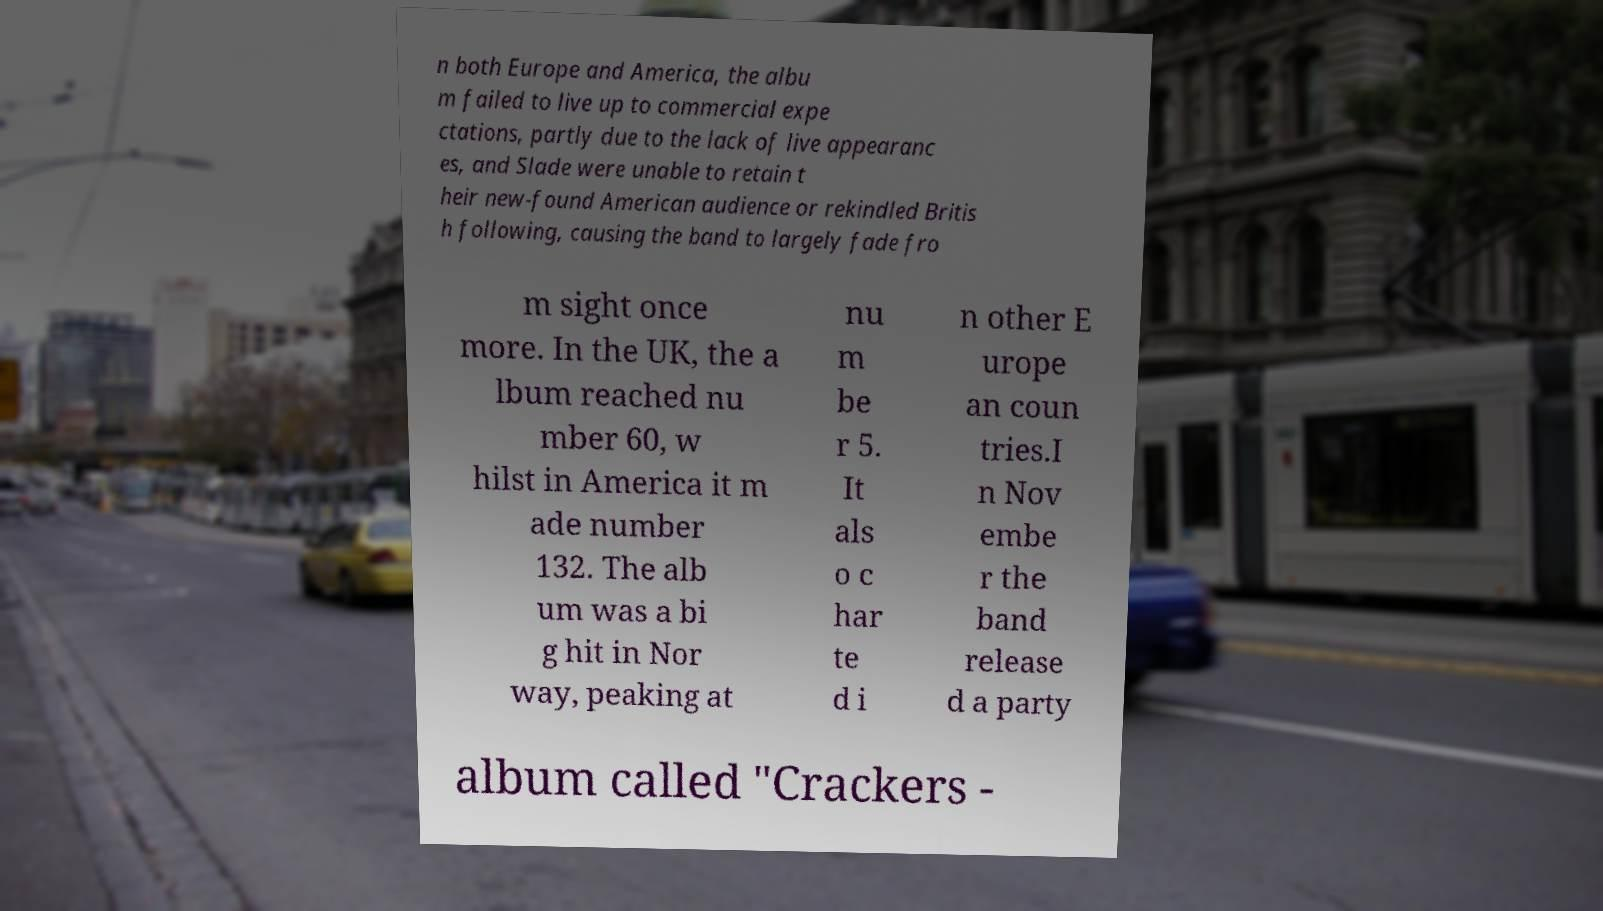Can you accurately transcribe the text from the provided image for me? n both Europe and America, the albu m failed to live up to commercial expe ctations, partly due to the lack of live appearanc es, and Slade were unable to retain t heir new-found American audience or rekindled Britis h following, causing the band to largely fade fro m sight once more. In the UK, the a lbum reached nu mber 60, w hilst in America it m ade number 132. The alb um was a bi g hit in Nor way, peaking at nu m be r 5. It als o c har te d i n other E urope an coun tries.I n Nov embe r the band release d a party album called "Crackers - 